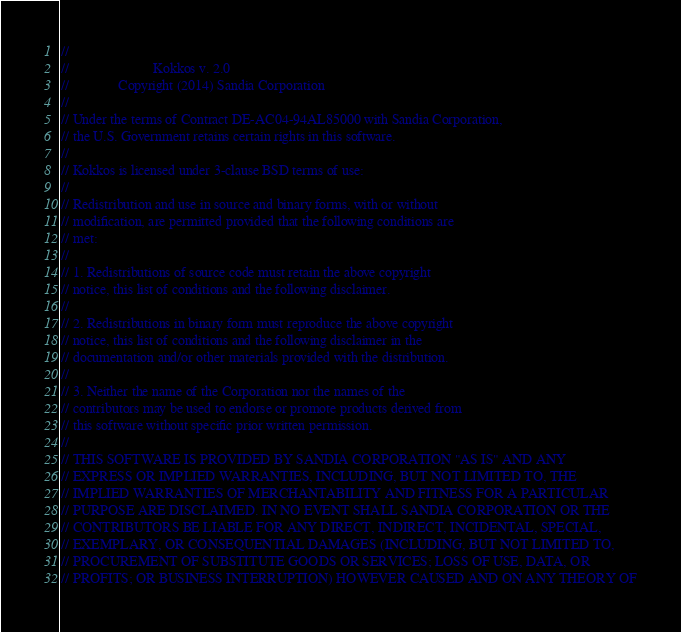Convert code to text. <code><loc_0><loc_0><loc_500><loc_500><_C++_>// 
//                        Kokkos v. 2.0
//              Copyright (2014) Sandia Corporation
// 
// Under the terms of Contract DE-AC04-94AL85000 with Sandia Corporation,
// the U.S. Government retains certain rights in this software.
//
// Kokkos is licensed under 3-clause BSD terms of use:
// 
// Redistribution and use in source and binary forms, with or without
// modification, are permitted provided that the following conditions are
// met:
//
// 1. Redistributions of source code must retain the above copyright
// notice, this list of conditions and the following disclaimer.
//
// 2. Redistributions in binary form must reproduce the above copyright
// notice, this list of conditions and the following disclaimer in the
// documentation and/or other materials provided with the distribution.
//
// 3. Neither the name of the Corporation nor the names of the
// contributors may be used to endorse or promote products derived from
// this software without specific prior written permission.
//
// THIS SOFTWARE IS PROVIDED BY SANDIA CORPORATION "AS IS" AND ANY
// EXPRESS OR IMPLIED WARRANTIES, INCLUDING, BUT NOT LIMITED TO, THE
// IMPLIED WARRANTIES OF MERCHANTABILITY AND FITNESS FOR A PARTICULAR
// PURPOSE ARE DISCLAIMED. IN NO EVENT SHALL SANDIA CORPORATION OR THE
// CONTRIBUTORS BE LIABLE FOR ANY DIRECT, INDIRECT, INCIDENTAL, SPECIAL,
// EXEMPLARY, OR CONSEQUENTIAL DAMAGES (INCLUDING, BUT NOT LIMITED TO,
// PROCUREMENT OF SUBSTITUTE GOODS OR SERVICES; LOSS OF USE, DATA, OR
// PROFITS; OR BUSINESS INTERRUPTION) HOWEVER CAUSED AND ON ANY THEORY OF</code> 